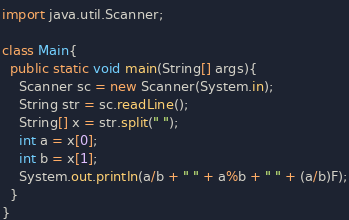<code> <loc_0><loc_0><loc_500><loc_500><_Java_>import java.util.Scanner;

class Main{
  public static void main(String[] args){
    Scanner sc = new Scanner(System.in);
    String str = sc.readLine();
    String[] x = str.split(" ");
    int a = x[0];
    int b = x[1];
    System.out.println(a/b + " " + a%b + " " + (a/b)F);
  }
}
</code> 